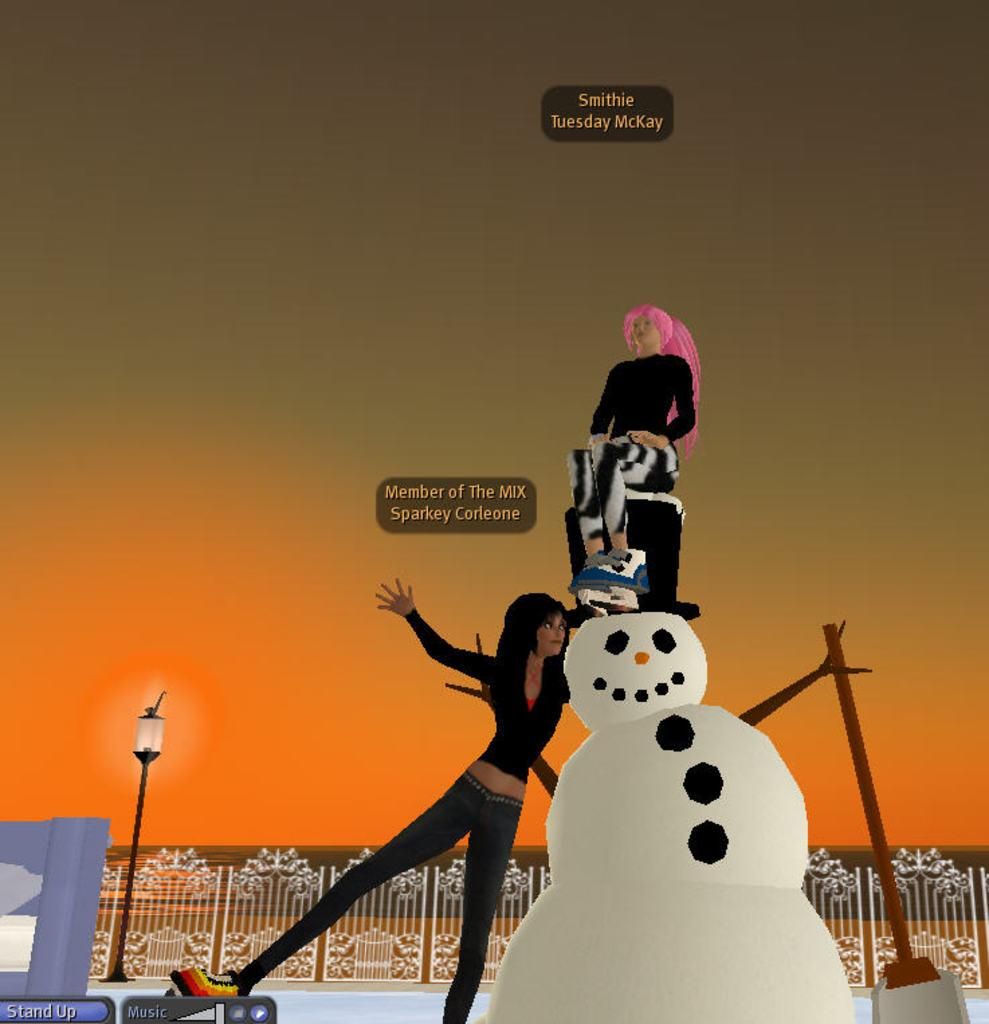What type of image is being described? The image is an animated picture. What is the main subject in the image? There is a snowman in the image. How many people are present in the image? Two people are standing in the image. What can be seen in the background of the image? There is a pole with a light, a fence, and the sky visible in the background. What is the income of the snowman in the image? The snowman in the image is not a living being and therefore does not have an income. How many steps are visible in the image? There is no mention of steps in the image; it features a snowman, two people, and background elements. 